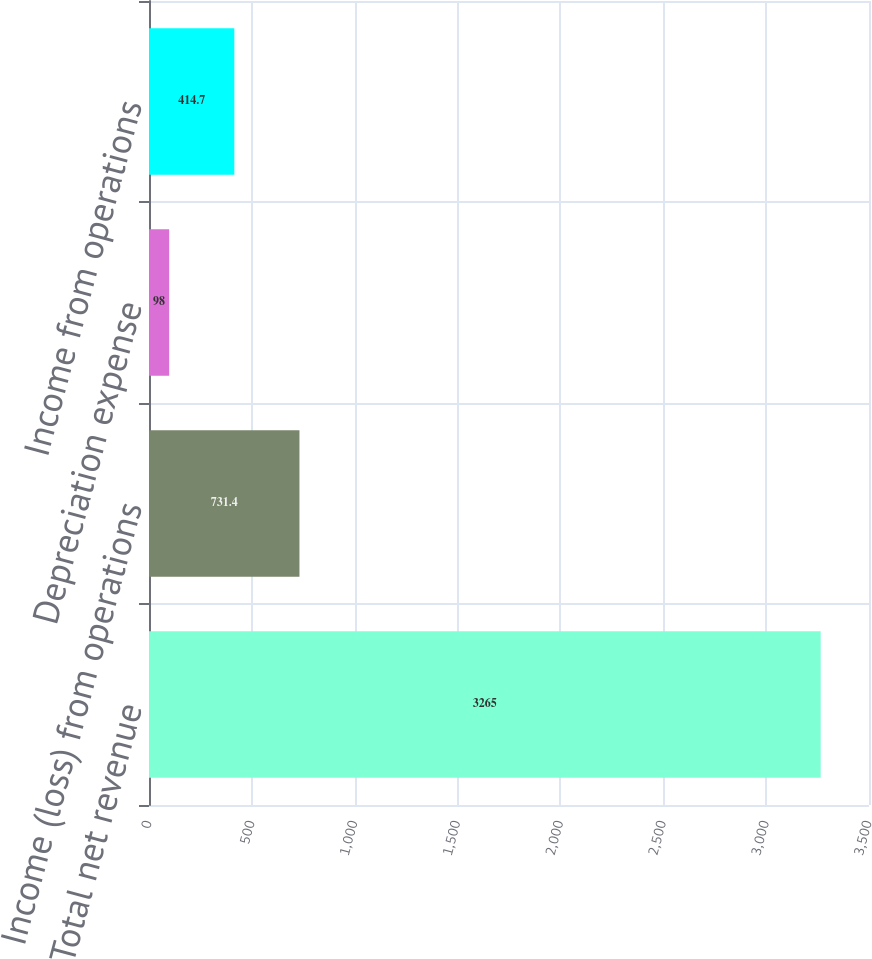Convert chart. <chart><loc_0><loc_0><loc_500><loc_500><bar_chart><fcel>Total net revenue<fcel>Income (loss) from operations<fcel>Depreciation expense<fcel>Income from operations<nl><fcel>3265<fcel>731.4<fcel>98<fcel>414.7<nl></chart> 